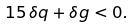Convert formula to latex. <formula><loc_0><loc_0><loc_500><loc_500>1 5 \, \delta q + \delta g < 0 .</formula> 